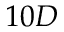Convert formula to latex. <formula><loc_0><loc_0><loc_500><loc_500>1 0 D</formula> 